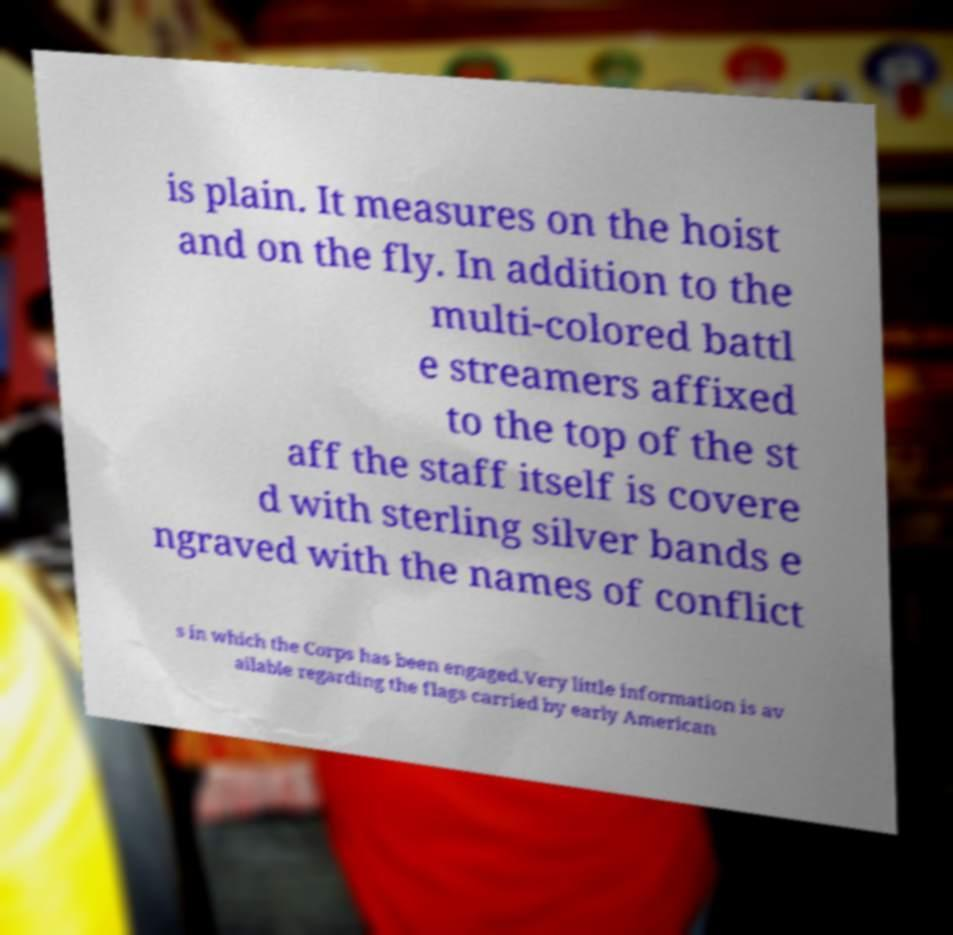Could you assist in decoding the text presented in this image and type it out clearly? is plain. It measures on the hoist and on the fly. In addition to the multi-colored battl e streamers affixed to the top of the st aff the staff itself is covere d with sterling silver bands e ngraved with the names of conflict s in which the Corps has been engaged.Very little information is av ailable regarding the flags carried by early American 